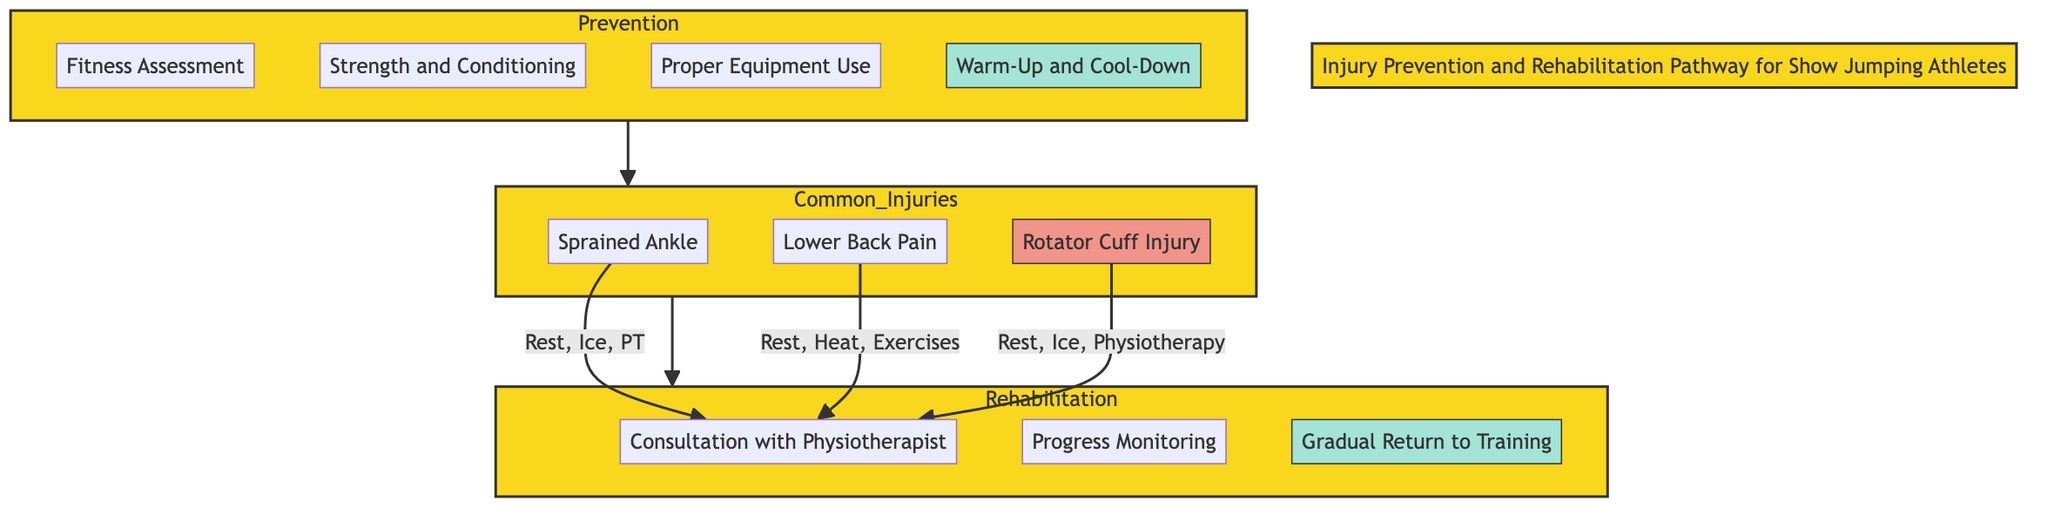What is the first step in the Prevention phase? The first step listed under the Prevention phase is "Fitness Assessment," which comes before all other steps in that section.
Answer: Fitness Assessment How many common injuries are listed in the diagram? The diagram lists three common injuries under the Common Injuries phase: "Sprained Ankle," "Lower Back Pain," and "Rotator Cuff Injury."
Answer: 3 What treatment follows the "Rest and Anti-Inflammatory Medication" for Lower Back Pain? After "Rest and Anti-Inflammatory Medication," the next treatment step for Lower Back Pain is "Heat Therapy," as listed in the treatment sequence.
Answer: Heat Therapy What is the main purpose of the "Gradual Return to Training" step? The "Gradual Return to Training" step aims to facilitate a slow re-introduction to training routines to prevent re-injury after recovery, as outlined in the description.
Answer: Prevent re-injury Which treatment is common to both Rotator Cuff Injury and Sprained Ankle? Both Rotator Cuff Injury and Sprained Ankle include "Rest" as a common treatment step at the beginning of their respective treatment plans.
Answer: Rest How long is the duration for "Progress Monitoring"? The duration specified for "Progress Monitoring" is "Weekly," indicating that it occurs once a week throughout the rehabilitation process.
Answer: Weekly What is the total number of steps in the Rehabilitation phase? There are three steps in the Rehabilitation phase: "Consultation with Physiotherapist," "Progress Monitoring," and "Gradual Return to Training," making a total of three.
Answer: 3 What outcome is associated with completing the "Fitness Assessment"? Completing the "Fitness Assessment" allows for an initial evaluation of the athlete's physical condition, which is crucial for tailoring injury prevention strategies.
Answer: Initial evaluation Which treatment duration is given for "Physical Therapy" in the case of a Sprained Ankle? The treatment duration for "Physical Therapy" in the case of a Sprained Ankle is listed as "2-4 weeks," indicating the time frame for recovery support.
Answer: 2-4 weeks 